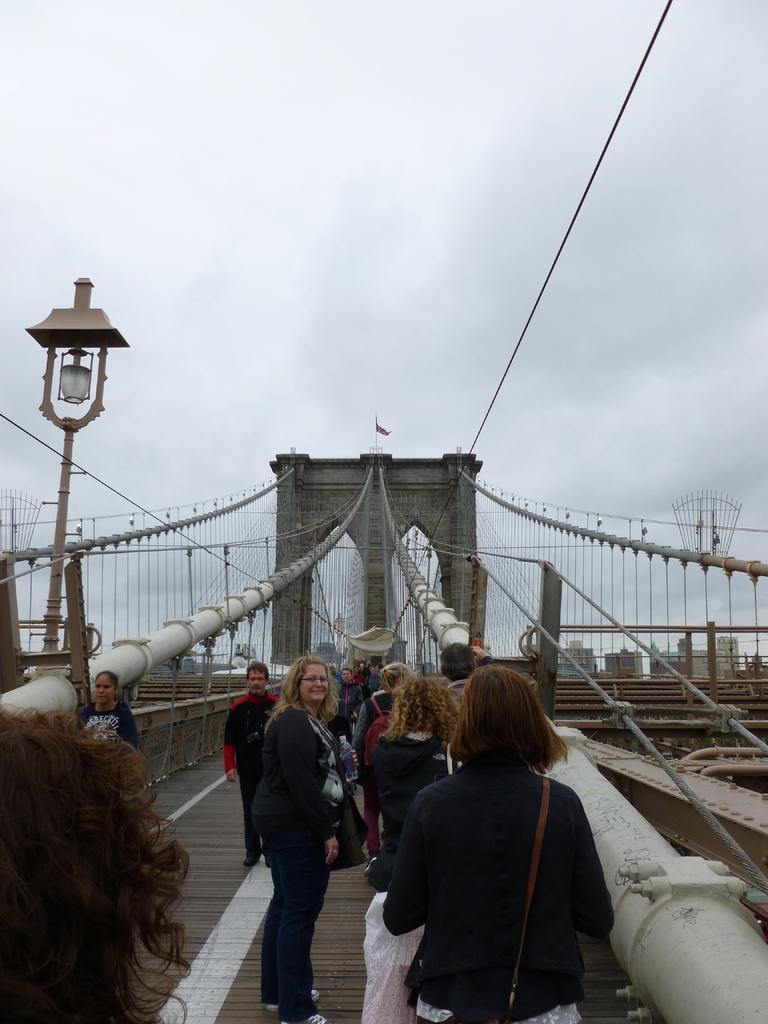How would you summarize this image in a sentence or two? This image is taken outdoors. At the top of the image there is a sky with clouds. At the bottom of the image there is a bridge with railings, ropes, grills, walls and pillars. On the left side of the image there is a light. In the middle of the image a few people are standing on the bridge. 